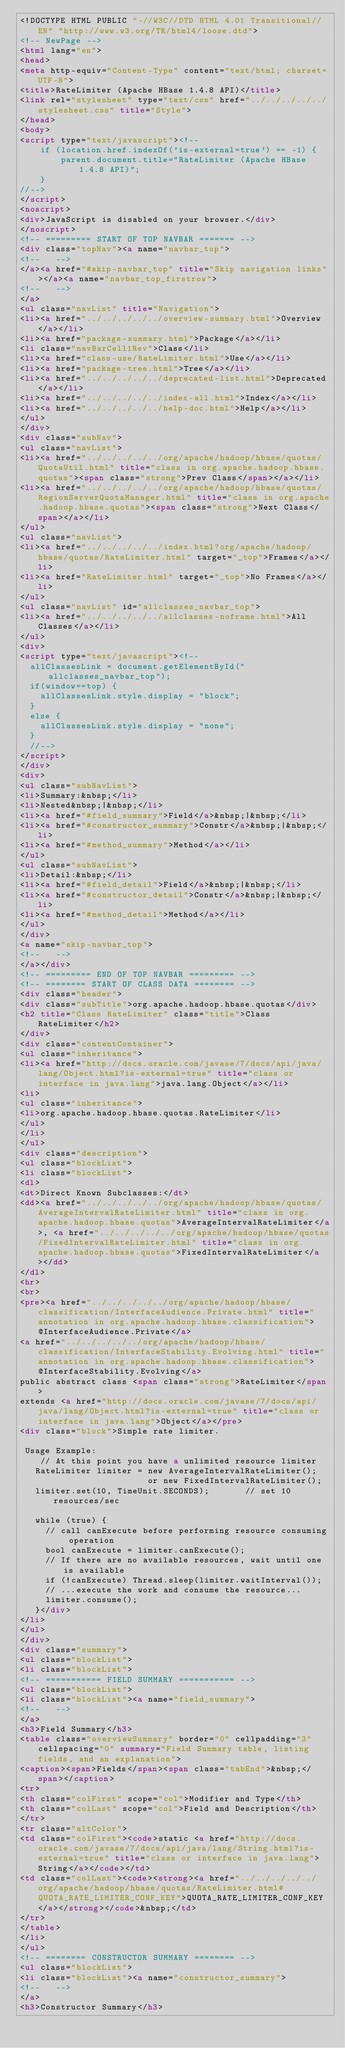Convert code to text. <code><loc_0><loc_0><loc_500><loc_500><_HTML_><!DOCTYPE HTML PUBLIC "-//W3C//DTD HTML 4.01 Transitional//EN" "http://www.w3.org/TR/html4/loose.dtd">
<!-- NewPage -->
<html lang="en">
<head>
<meta http-equiv="Content-Type" content="text/html; charset=UTF-8">
<title>RateLimiter (Apache HBase 1.4.8 API)</title>
<link rel="stylesheet" type="text/css" href="../../../../../stylesheet.css" title="Style">
</head>
<body>
<script type="text/javascript"><!--
    if (location.href.indexOf('is-external=true') == -1) {
        parent.document.title="RateLimiter (Apache HBase 1.4.8 API)";
    }
//-->
</script>
<noscript>
<div>JavaScript is disabled on your browser.</div>
</noscript>
<!-- ========= START OF TOP NAVBAR ======= -->
<div class="topNav"><a name="navbar_top">
<!--   -->
</a><a href="#skip-navbar_top" title="Skip navigation links"></a><a name="navbar_top_firstrow">
<!--   -->
</a>
<ul class="navList" title="Navigation">
<li><a href="../../../../../overview-summary.html">Overview</a></li>
<li><a href="package-summary.html">Package</a></li>
<li class="navBarCell1Rev">Class</li>
<li><a href="class-use/RateLimiter.html">Use</a></li>
<li><a href="package-tree.html">Tree</a></li>
<li><a href="../../../../../deprecated-list.html">Deprecated</a></li>
<li><a href="../../../../../index-all.html">Index</a></li>
<li><a href="../../../../../help-doc.html">Help</a></li>
</ul>
</div>
<div class="subNav">
<ul class="navList">
<li><a href="../../../../../org/apache/hadoop/hbase/quotas/QuotaUtil.html" title="class in org.apache.hadoop.hbase.quotas"><span class="strong">Prev Class</span></a></li>
<li><a href="../../../../../org/apache/hadoop/hbase/quotas/RegionServerQuotaManager.html" title="class in org.apache.hadoop.hbase.quotas"><span class="strong">Next Class</span></a></li>
</ul>
<ul class="navList">
<li><a href="../../../../../index.html?org/apache/hadoop/hbase/quotas/RateLimiter.html" target="_top">Frames</a></li>
<li><a href="RateLimiter.html" target="_top">No Frames</a></li>
</ul>
<ul class="navList" id="allclasses_navbar_top">
<li><a href="../../../../../allclasses-noframe.html">All Classes</a></li>
</ul>
<div>
<script type="text/javascript"><!--
  allClassesLink = document.getElementById("allclasses_navbar_top");
  if(window==top) {
    allClassesLink.style.display = "block";
  }
  else {
    allClassesLink.style.display = "none";
  }
  //-->
</script>
</div>
<div>
<ul class="subNavList">
<li>Summary:&nbsp;</li>
<li>Nested&nbsp;|&nbsp;</li>
<li><a href="#field_summary">Field</a>&nbsp;|&nbsp;</li>
<li><a href="#constructor_summary">Constr</a>&nbsp;|&nbsp;</li>
<li><a href="#method_summary">Method</a></li>
</ul>
<ul class="subNavList">
<li>Detail:&nbsp;</li>
<li><a href="#field_detail">Field</a>&nbsp;|&nbsp;</li>
<li><a href="#constructor_detail">Constr</a>&nbsp;|&nbsp;</li>
<li><a href="#method_detail">Method</a></li>
</ul>
</div>
<a name="skip-navbar_top">
<!--   -->
</a></div>
<!-- ========= END OF TOP NAVBAR ========= -->
<!-- ======== START OF CLASS DATA ======== -->
<div class="header">
<div class="subTitle">org.apache.hadoop.hbase.quotas</div>
<h2 title="Class RateLimiter" class="title">Class RateLimiter</h2>
</div>
<div class="contentContainer">
<ul class="inheritance">
<li><a href="http://docs.oracle.com/javase/7/docs/api/java/lang/Object.html?is-external=true" title="class or interface in java.lang">java.lang.Object</a></li>
<li>
<ul class="inheritance">
<li>org.apache.hadoop.hbase.quotas.RateLimiter</li>
</ul>
</li>
</ul>
<div class="description">
<ul class="blockList">
<li class="blockList">
<dl>
<dt>Direct Known Subclasses:</dt>
<dd><a href="../../../../../org/apache/hadoop/hbase/quotas/AverageIntervalRateLimiter.html" title="class in org.apache.hadoop.hbase.quotas">AverageIntervalRateLimiter</a>, <a href="../../../../../org/apache/hadoop/hbase/quotas/FixedIntervalRateLimiter.html" title="class in org.apache.hadoop.hbase.quotas">FixedIntervalRateLimiter</a></dd>
</dl>
<hr>
<br>
<pre><a href="../../../../../org/apache/hadoop/hbase/classification/InterfaceAudience.Private.html" title="annotation in org.apache.hadoop.hbase.classification">@InterfaceAudience.Private</a>
<a href="../../../../../org/apache/hadoop/hbase/classification/InterfaceStability.Evolving.html" title="annotation in org.apache.hadoop.hbase.classification">@InterfaceStability.Evolving</a>
public abstract class <span class="strong">RateLimiter</span>
extends <a href="http://docs.oracle.com/javase/7/docs/api/java/lang/Object.html?is-external=true" title="class or interface in java.lang">Object</a></pre>
<div class="block">Simple rate limiter.

 Usage Example:
    // At this point you have a unlimited resource limiter
   RateLimiter limiter = new AverageIntervalRateLimiter();
                         or new FixedIntervalRateLimiter();
   limiter.set(10, TimeUnit.SECONDS);       // set 10 resources/sec

   while (true) {
     // call canExecute before performing resource consuming operation
     bool canExecute = limiter.canExecute();
     // If there are no available resources, wait until one is available
     if (!canExecute) Thread.sleep(limiter.waitInterval());
     // ...execute the work and consume the resource...
     limiter.consume();
   }</div>
</li>
</ul>
</div>
<div class="summary">
<ul class="blockList">
<li class="blockList">
<!-- =========== FIELD SUMMARY =========== -->
<ul class="blockList">
<li class="blockList"><a name="field_summary">
<!--   -->
</a>
<h3>Field Summary</h3>
<table class="overviewSummary" border="0" cellpadding="3" cellspacing="0" summary="Field Summary table, listing fields, and an explanation">
<caption><span>Fields</span><span class="tabEnd">&nbsp;</span></caption>
<tr>
<th class="colFirst" scope="col">Modifier and Type</th>
<th class="colLast" scope="col">Field and Description</th>
</tr>
<tr class="altColor">
<td class="colFirst"><code>static <a href="http://docs.oracle.com/javase/7/docs/api/java/lang/String.html?is-external=true" title="class or interface in java.lang">String</a></code></td>
<td class="colLast"><code><strong><a href="../../../../../org/apache/hadoop/hbase/quotas/RateLimiter.html#QUOTA_RATE_LIMITER_CONF_KEY">QUOTA_RATE_LIMITER_CONF_KEY</a></strong></code>&nbsp;</td>
</tr>
</table>
</li>
</ul>
<!-- ======== CONSTRUCTOR SUMMARY ======== -->
<ul class="blockList">
<li class="blockList"><a name="constructor_summary">
<!--   -->
</a>
<h3>Constructor Summary</h3></code> 